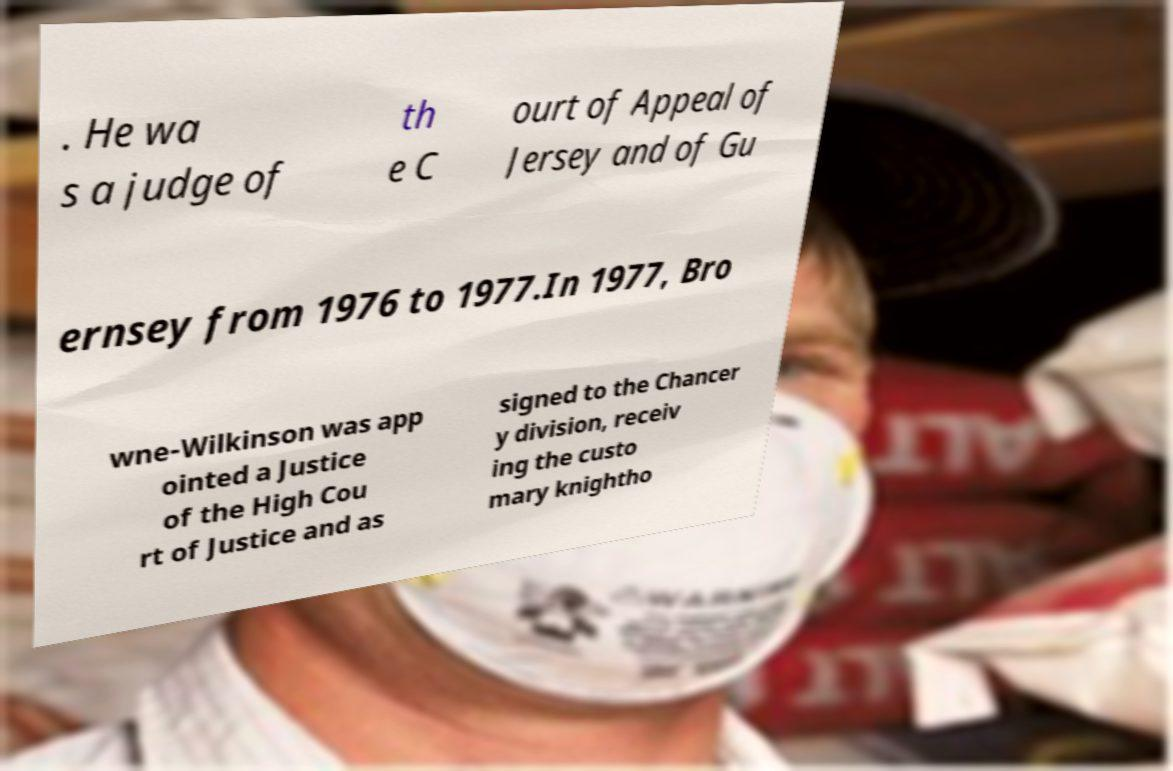What messages or text are displayed in this image? I need them in a readable, typed format. . He wa s a judge of th e C ourt of Appeal of Jersey and of Gu ernsey from 1976 to 1977.In 1977, Bro wne-Wilkinson was app ointed a Justice of the High Cou rt of Justice and as signed to the Chancer y division, receiv ing the custo mary knightho 